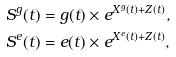<formula> <loc_0><loc_0><loc_500><loc_500>S ^ { g } ( t ) & = g ( t ) \times e ^ { X ^ { g } ( t ) + Z ( t ) } , \\ S ^ { e } ( t ) & = e ( t ) \times e ^ { X ^ { e } ( t ) + Z ( t ) } ,</formula> 